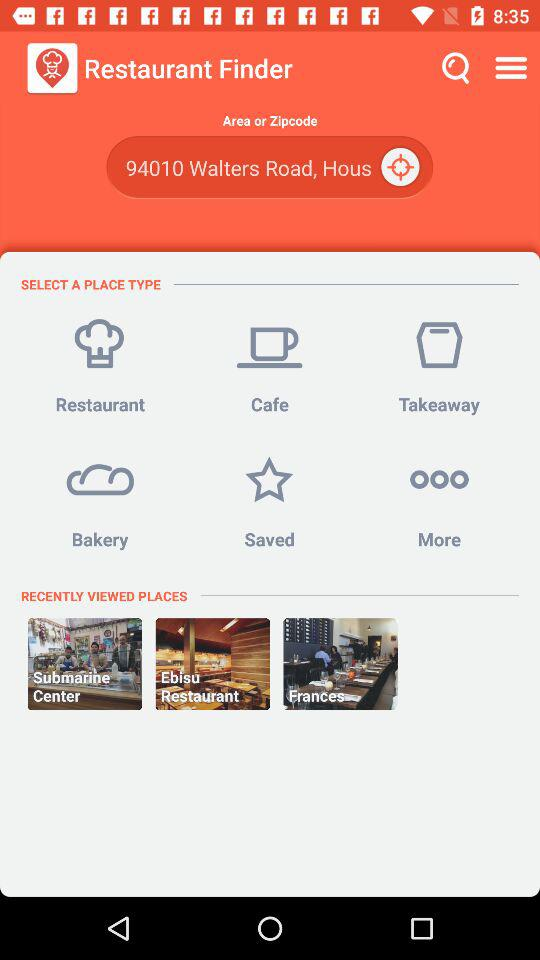What's the entered location in the search field in "Restaurant Finder"? The entered location is 94010 Walters Road, Hous. 